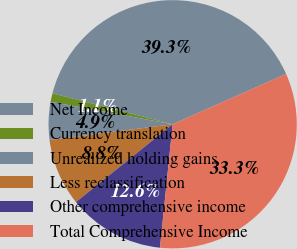<chart> <loc_0><loc_0><loc_500><loc_500><pie_chart><fcel>Net Income<fcel>Currency translation<fcel>Unrealized holding gains<fcel>Less reclassification<fcel>Other comprehensive income<fcel>Total Comprehensive Income<nl><fcel>39.34%<fcel>1.11%<fcel>4.93%<fcel>8.76%<fcel>12.58%<fcel>33.27%<nl></chart> 